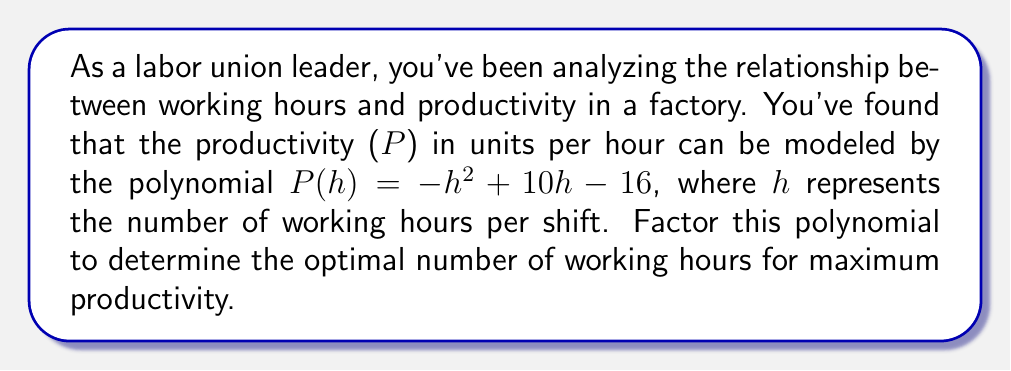Show me your answer to this math problem. To factor this polynomial, we'll follow these steps:

1) First, we recognize that this is a quadratic polynomial in the form $ax^2 + bx + c$, where:
   $a = -1$, $b = 10$, and $c = -16$

2) We can factor this using the quadratic formula or by finding two numbers that multiply to $ac$ and add up to $b$. Let's use the second method.

3) We need to find two numbers that multiply to $(-1)(-16) = 16$ and add up to 10.
   These numbers are 8 and 2.

4) We can rewrite the middle term using these numbers:
   $P(h) = -h^2 + 8h + 2h - 16$

5) Now we can factor by grouping:
   $P(h) = (-h^2 + 8h) + (2h - 16)$
   $P(h) = -h(h - 8) + 2(h - 8)$
   $P(h) = (h - 8)(-h + 2)$

6) Rearranging to standard form:
   $P(h) = -(h - 8)(h - 2)$

7) The roots of this polynomial (where $P(h) = 0$) are at $h = 8$ and $h = 2$. 
   The optimal number of working hours will be halfway between these roots, at $h = 5$.

This factorization allows us to easily see that productivity reaches its maximum when the number of working hours is 5 per shift, which could be valuable information for negotiating fair and productive working conditions.
Answer: $P(h) = -(h - 8)(h - 2)$ 